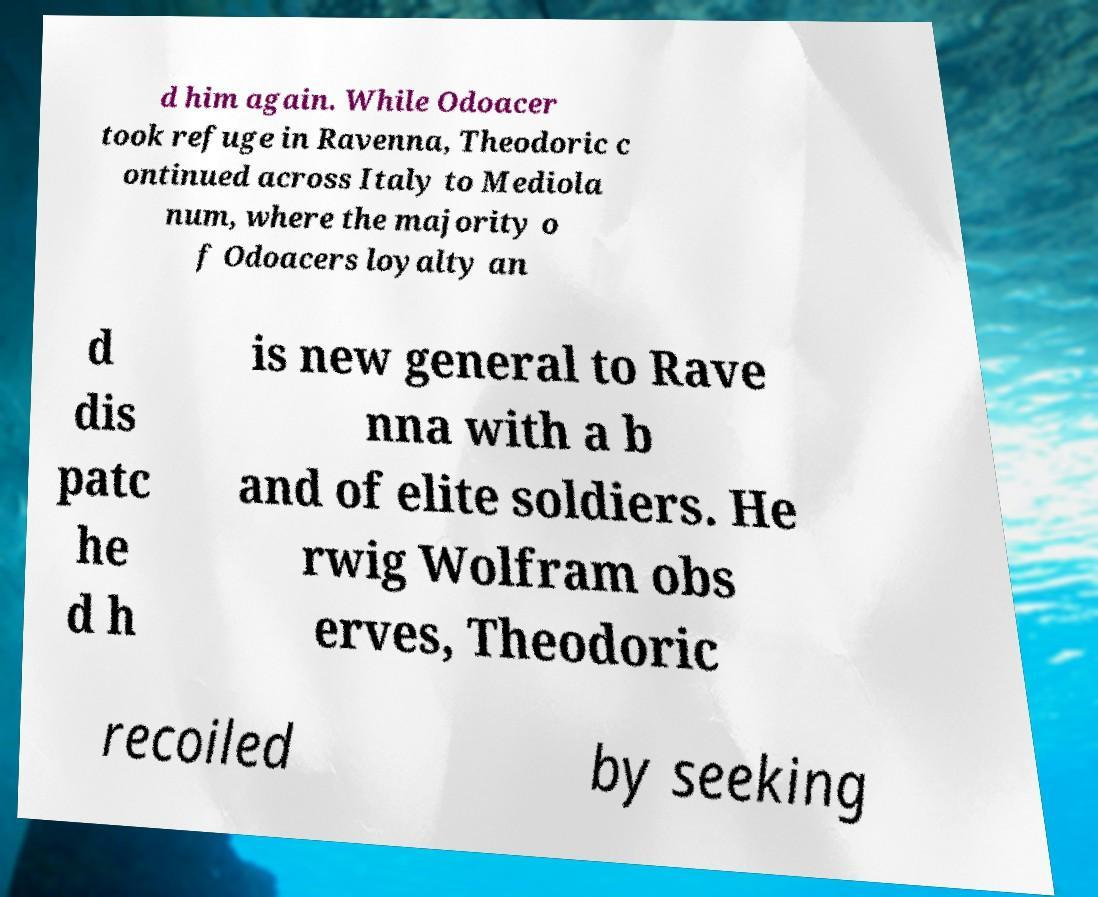Please read and relay the text visible in this image. What does it say? d him again. While Odoacer took refuge in Ravenna, Theodoric c ontinued across Italy to Mediola num, where the majority o f Odoacers loyalty an d dis patc he d h is new general to Rave nna with a b and of elite soldiers. He rwig Wolfram obs erves, Theodoric recoiled by seeking 